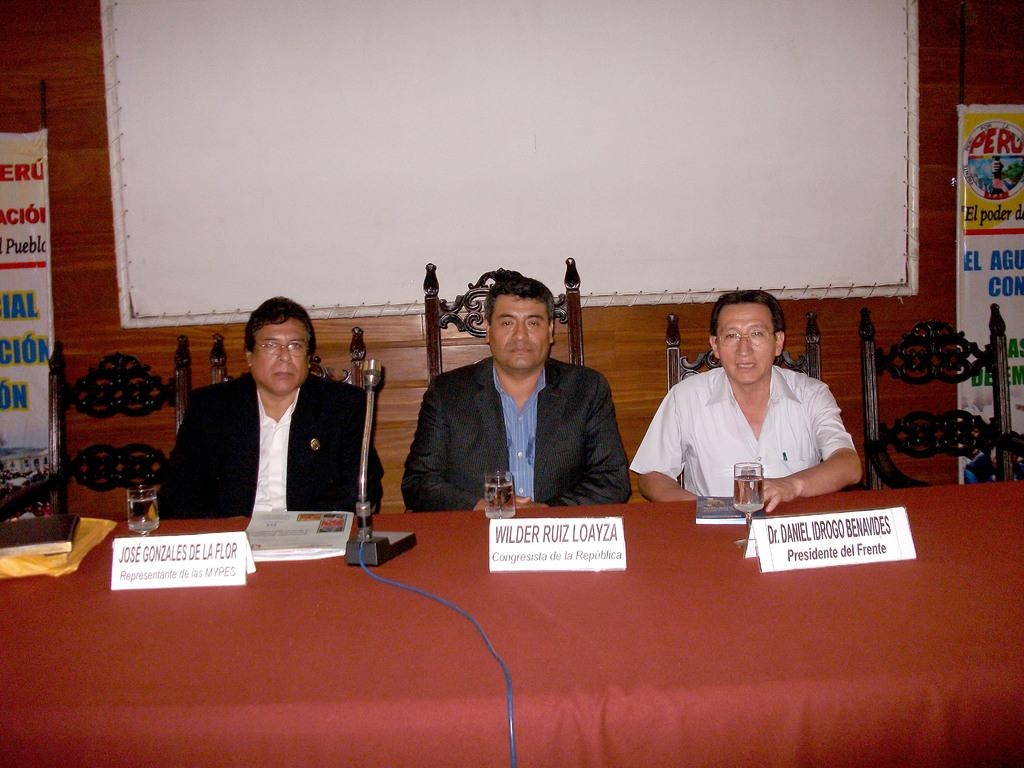<image>
Describe the image concisely. a man named Jose Gonzales with a name tag 